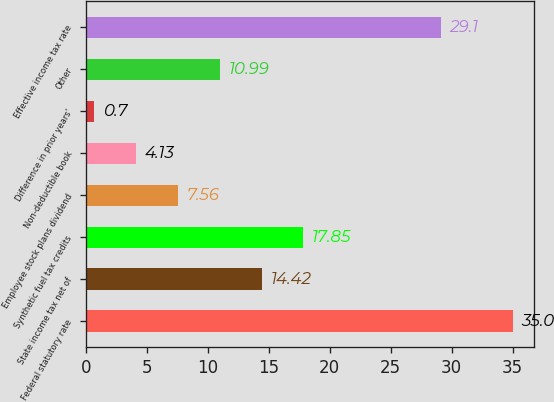Convert chart. <chart><loc_0><loc_0><loc_500><loc_500><bar_chart><fcel>Federal statutory rate<fcel>State income tax net of<fcel>Synthetic fuel tax credits<fcel>Employee stock plans dividend<fcel>Non-deductible book<fcel>Difference in prior years'<fcel>Other<fcel>Effective income tax rate<nl><fcel>35<fcel>14.42<fcel>17.85<fcel>7.56<fcel>4.13<fcel>0.7<fcel>10.99<fcel>29.1<nl></chart> 